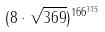Convert formula to latex. <formula><loc_0><loc_0><loc_500><loc_500>( 8 \cdot \sqrt { 3 6 9 } ) ^ { 1 6 6 ^ { 3 1 5 } }</formula> 